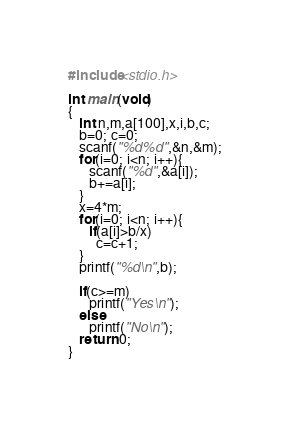Convert code to text. <code><loc_0><loc_0><loc_500><loc_500><_C_>#include<stdio.h>

int main(void)
{
   int n,m,a[100],x,i,b,c;
   b=0; c=0;
   scanf("%d%d",&n,&m);
   for(i=0; i<n; i++){
      scanf("%d",&a[i]);
      b+=a[i];
   }
   x=4*m;
   for(i=0; i<n; i++){
      if(a[i]>b/x)
        c=c+1;
   }
   printf("%d\n",b);

   if(c>=m)
      printf("Yes\n");
   else
      printf("No\n");
   return 0;
}
</code> 